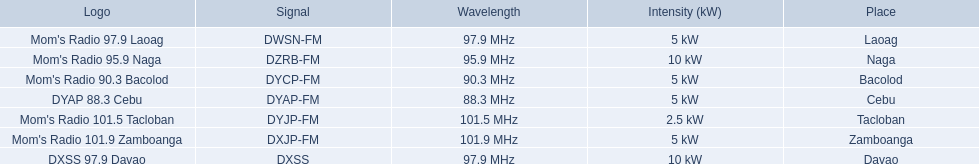Which stations broadcast in dyap-fm? Mom's Radio 97.9 Laoag, Mom's Radio 95.9 Naga, Mom's Radio 90.3 Bacolod, DYAP 88.3 Cebu, Mom's Radio 101.5 Tacloban, Mom's Radio 101.9 Zamboanga, DXSS 97.9 Davao. Of those stations which broadcast in dyap-fm, which stations broadcast with 5kw of power or under? Mom's Radio 97.9 Laoag, Mom's Radio 90.3 Bacolod, DYAP 88.3 Cebu, Mom's Radio 101.5 Tacloban, Mom's Radio 101.9 Zamboanga. Of those stations that broadcast with 5kw of power or under, which broadcasts with the least power? Mom's Radio 101.5 Tacloban. 